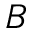<formula> <loc_0><loc_0><loc_500><loc_500>B</formula> 